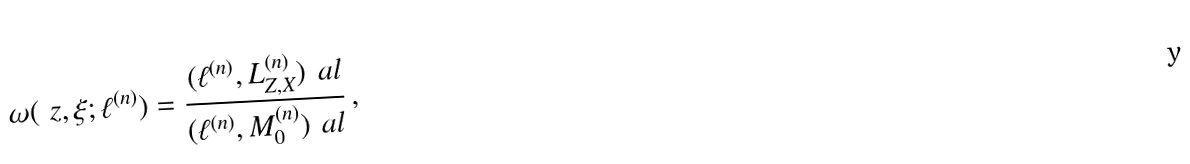<formula> <loc_0><loc_0><loc_500><loc_500>\omega ( \ z , \xi ; \ell ^ { ( n ) } ) = \frac { ( \ell ^ { ( n ) } , L ^ { ( n ) } _ { Z , X } ) _ { \ } a l } { ( \ell ^ { ( n ) } , { M ^ { ( n ) } _ { 0 } } ) _ { \ } a l } \, ,</formula> 